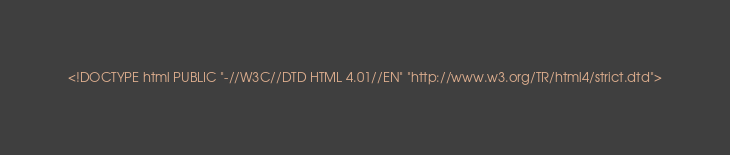<code> <loc_0><loc_0><loc_500><loc_500><_HTML_><!DOCTYPE html PUBLIC "-//W3C//DTD HTML 4.01//EN" "http://www.w3.org/TR/html4/strict.dtd"></code> 